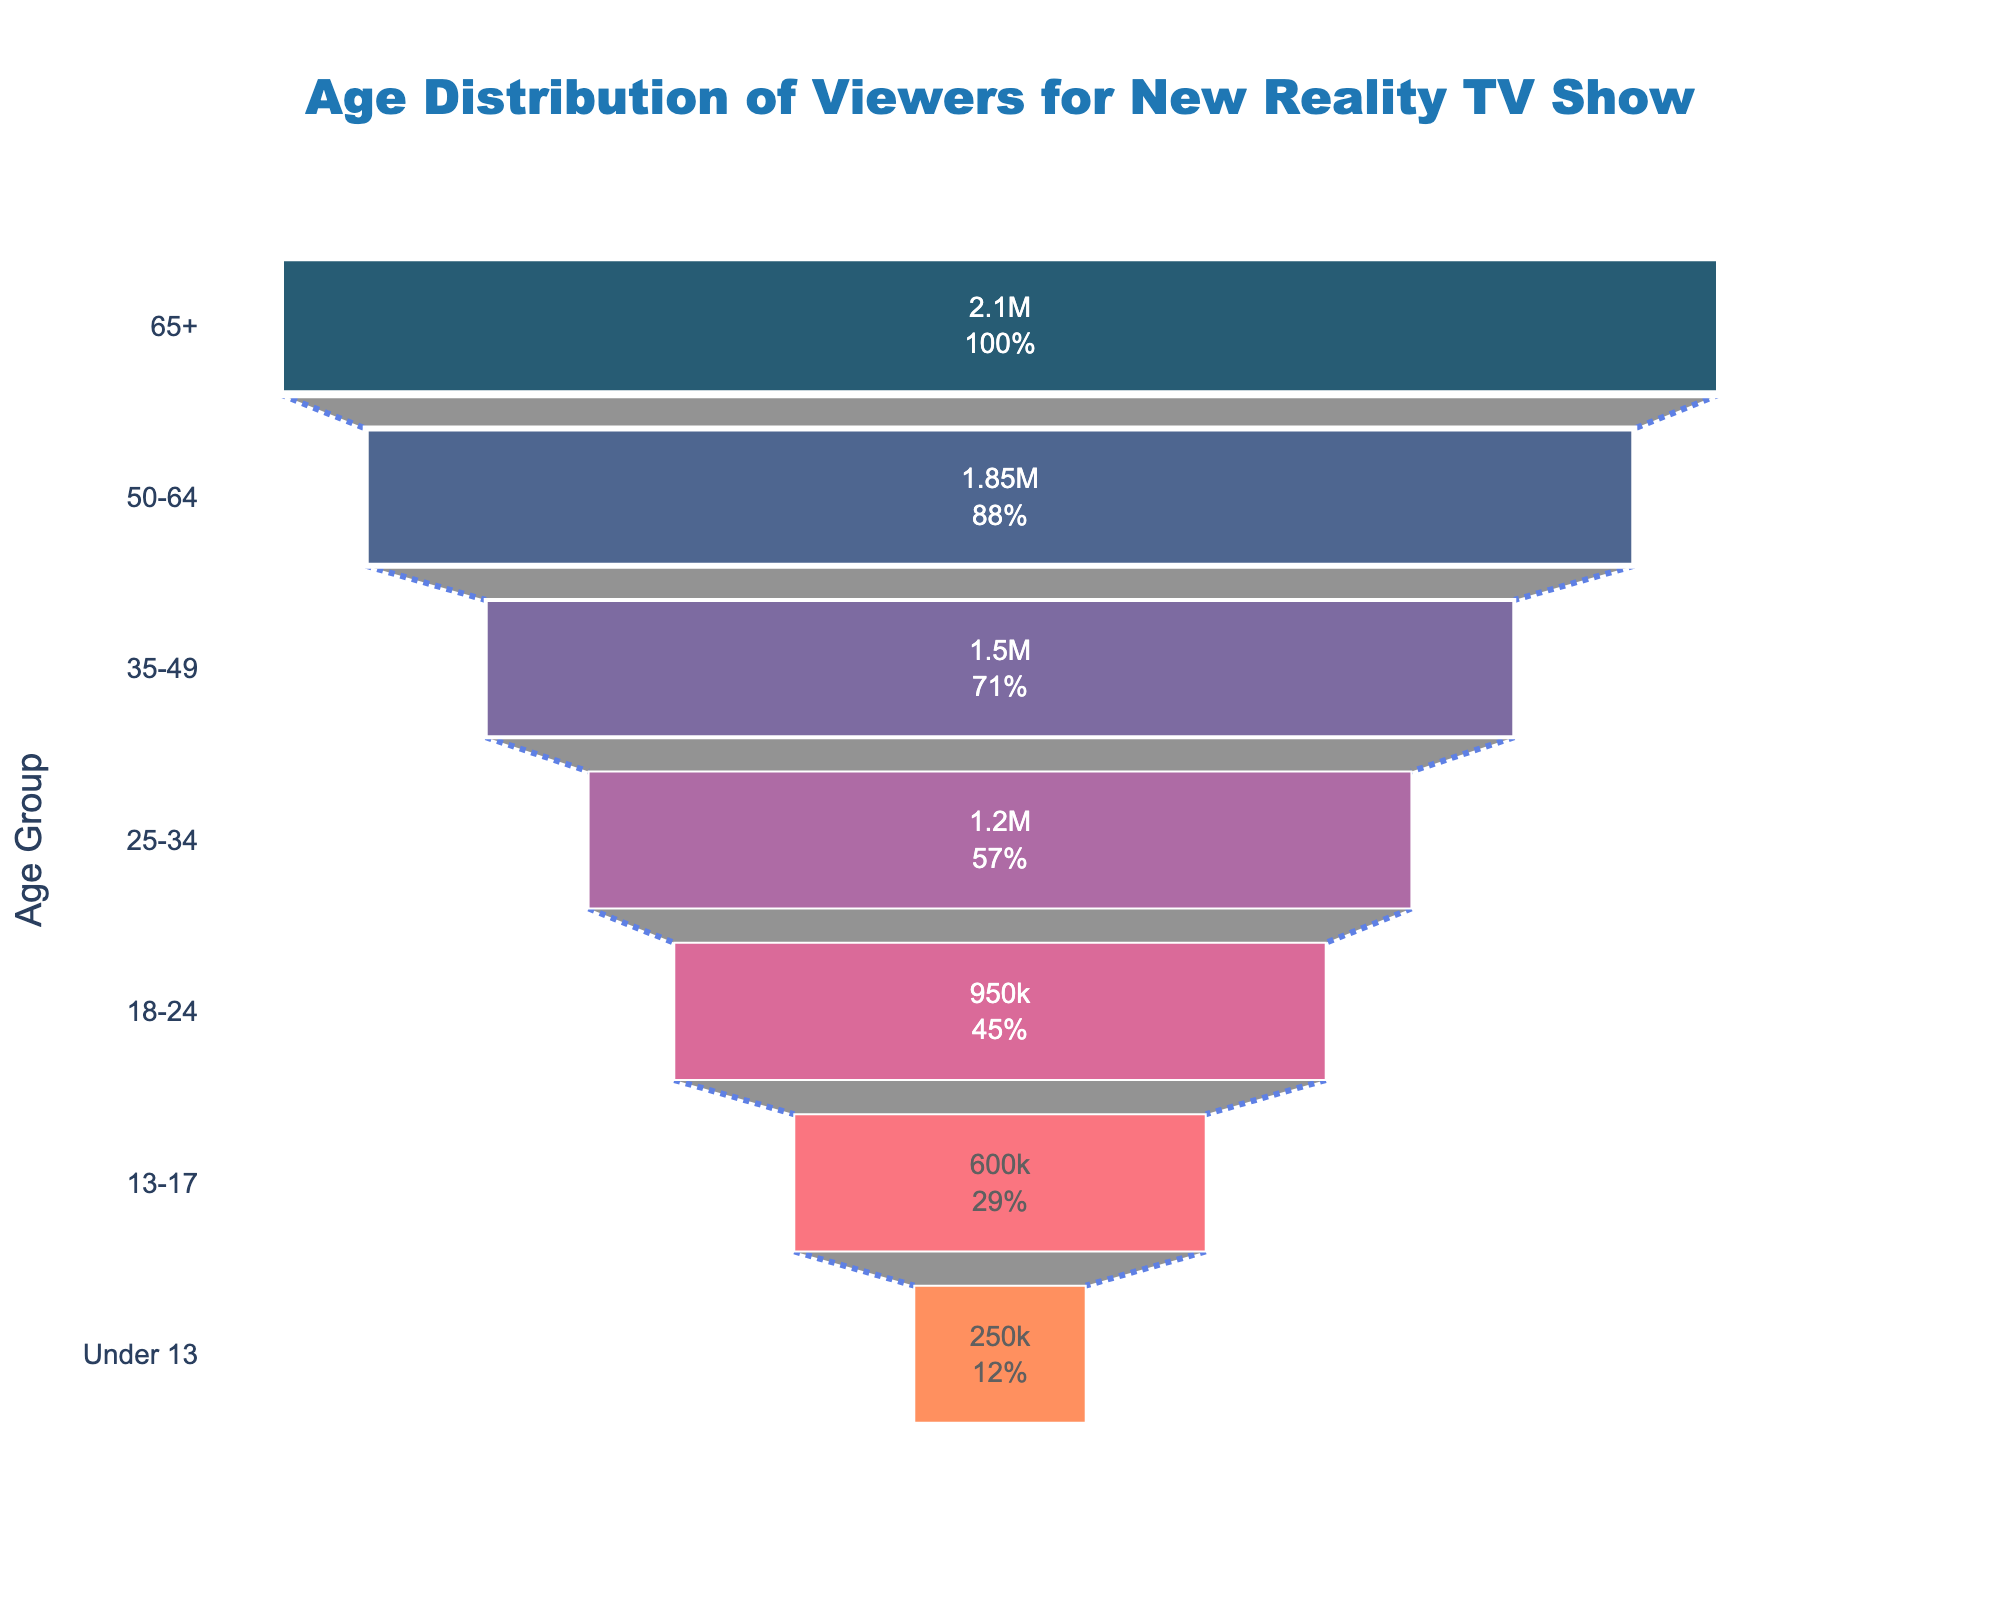What is the title of the figure? The title of the figure can be read directly from the top of the chart. It reads: "Age Distribution of Viewers for New Reality TV Show."
Answer: Age Distribution of Viewers for New Reality TV Show Which age group has the highest number of viewers? Observing the chart, the largest section is for the "65+" age group, which has the highest number of viewers.
Answer: 65+ Which age group has the lowest number of viewers? The smallest section in the chart corresponds to the "Under 13" age group.
Answer: Under 13 How many viewers are there in the 18-24 age group? The number inside the "18-24" section of the funnel chart can be directly observed. The number of viewers is 950,000.
Answer: 950,000 Compare the number of viewers between the 50-64 and 35-49 age groups. To compare, observe the numbers in both sections: 50-64 has 1,850,000 viewers, and 35-49 has 1,500,000 viewers. 50-64 has more viewers.
Answer: 50-64 has more viewers What percentage of initial viewers is from the 25-34 age group? In the funnel chart, each segment provides the percentage of initial viewers. The 25-34 age group shows "1200000 (18.5%)".
Answer: 18.5% What is the sum of viewers from the 50-64 and 35-49 age groups? Adding the viewers from the two age groups: 1,850,000 (50-64) + 1,500,000 (35-49) = 3,350,000.
Answer: 3,350,000 What is the average number of viewers for all age groups provided? Sum the viewers from all age groups and divide by the number of groups: (2,100,000 + 1,850,000 + 1,500,000 + 1,200,000 + 950,000 + 600,000 + 250,000) / 7 = 8,450,000 / 7 ≈ 1,207,143 viewers.
Answer: ≈ 1,207,143 viewers What can you infer about age distribution based on the funnel chart? Observing the funnel chart, the number of viewers generally decreases as the age group gets younger, indicating that the TV show's viewership skews older.
Answer: Older viewers dominate How does the number of viewers for the 13-17 age group compare to the Under 13 age group? The number of viewers for the 13-17 age group (600,000) is significantly higher than the number for the Under 13 age group (250,000).
Answer: 13-17 has more viewers 